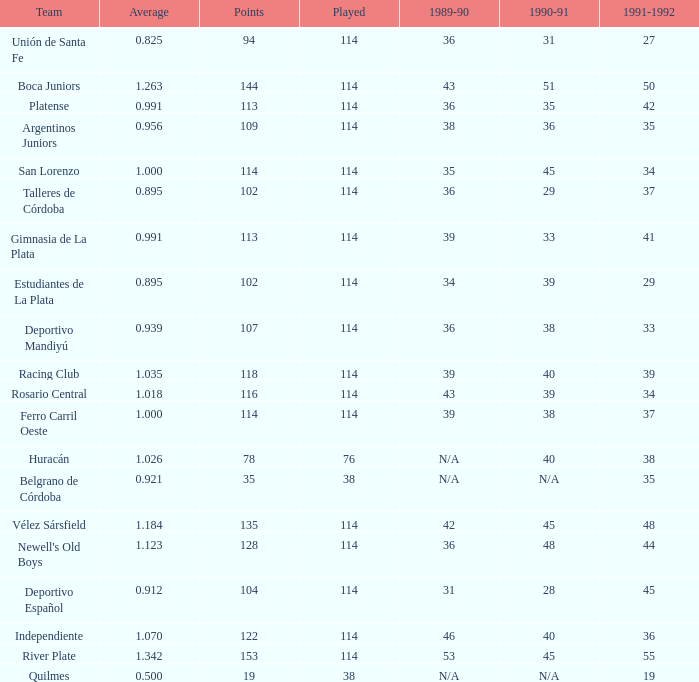How much Played has an Average smaller than 0.9390000000000001, and a 1990-91 of 28? 1.0. 